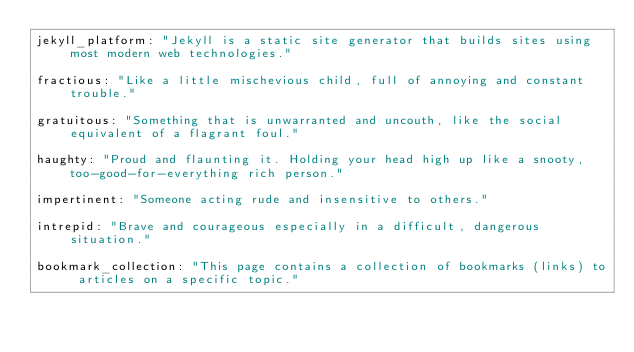<code> <loc_0><loc_0><loc_500><loc_500><_YAML_>jekyll_platform: "Jekyll is a static site generator that builds sites using most modern web technologies."

fractious: "Like a little mischevious child, full of annoying and constant trouble."

gratuitous: "Something that is unwarranted and uncouth, like the social equivalent of a flagrant foul."

haughty: "Proud and flaunting it. Holding your head high up like a snooty, too-good-for-everything rich person."

impertinent: "Someone acting rude and insensitive to others."

intrepid: "Brave and courageous especially in a difficult, dangerous situation."

bookmark_collection: "This page contains a collection of bookmarks (links) to articles on a specific topic."
</code> 